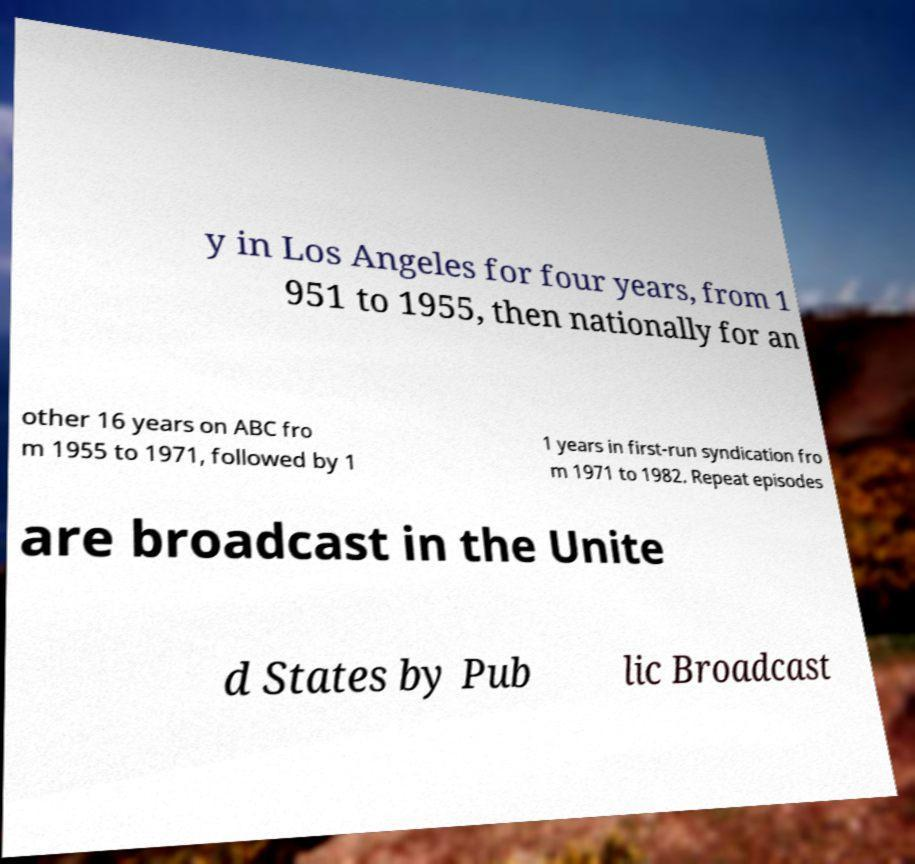Please identify and transcribe the text found in this image. y in Los Angeles for four years, from 1 951 to 1955, then nationally for an other 16 years on ABC fro m 1955 to 1971, followed by 1 1 years in first-run syndication fro m 1971 to 1982. Repeat episodes are broadcast in the Unite d States by Pub lic Broadcast 